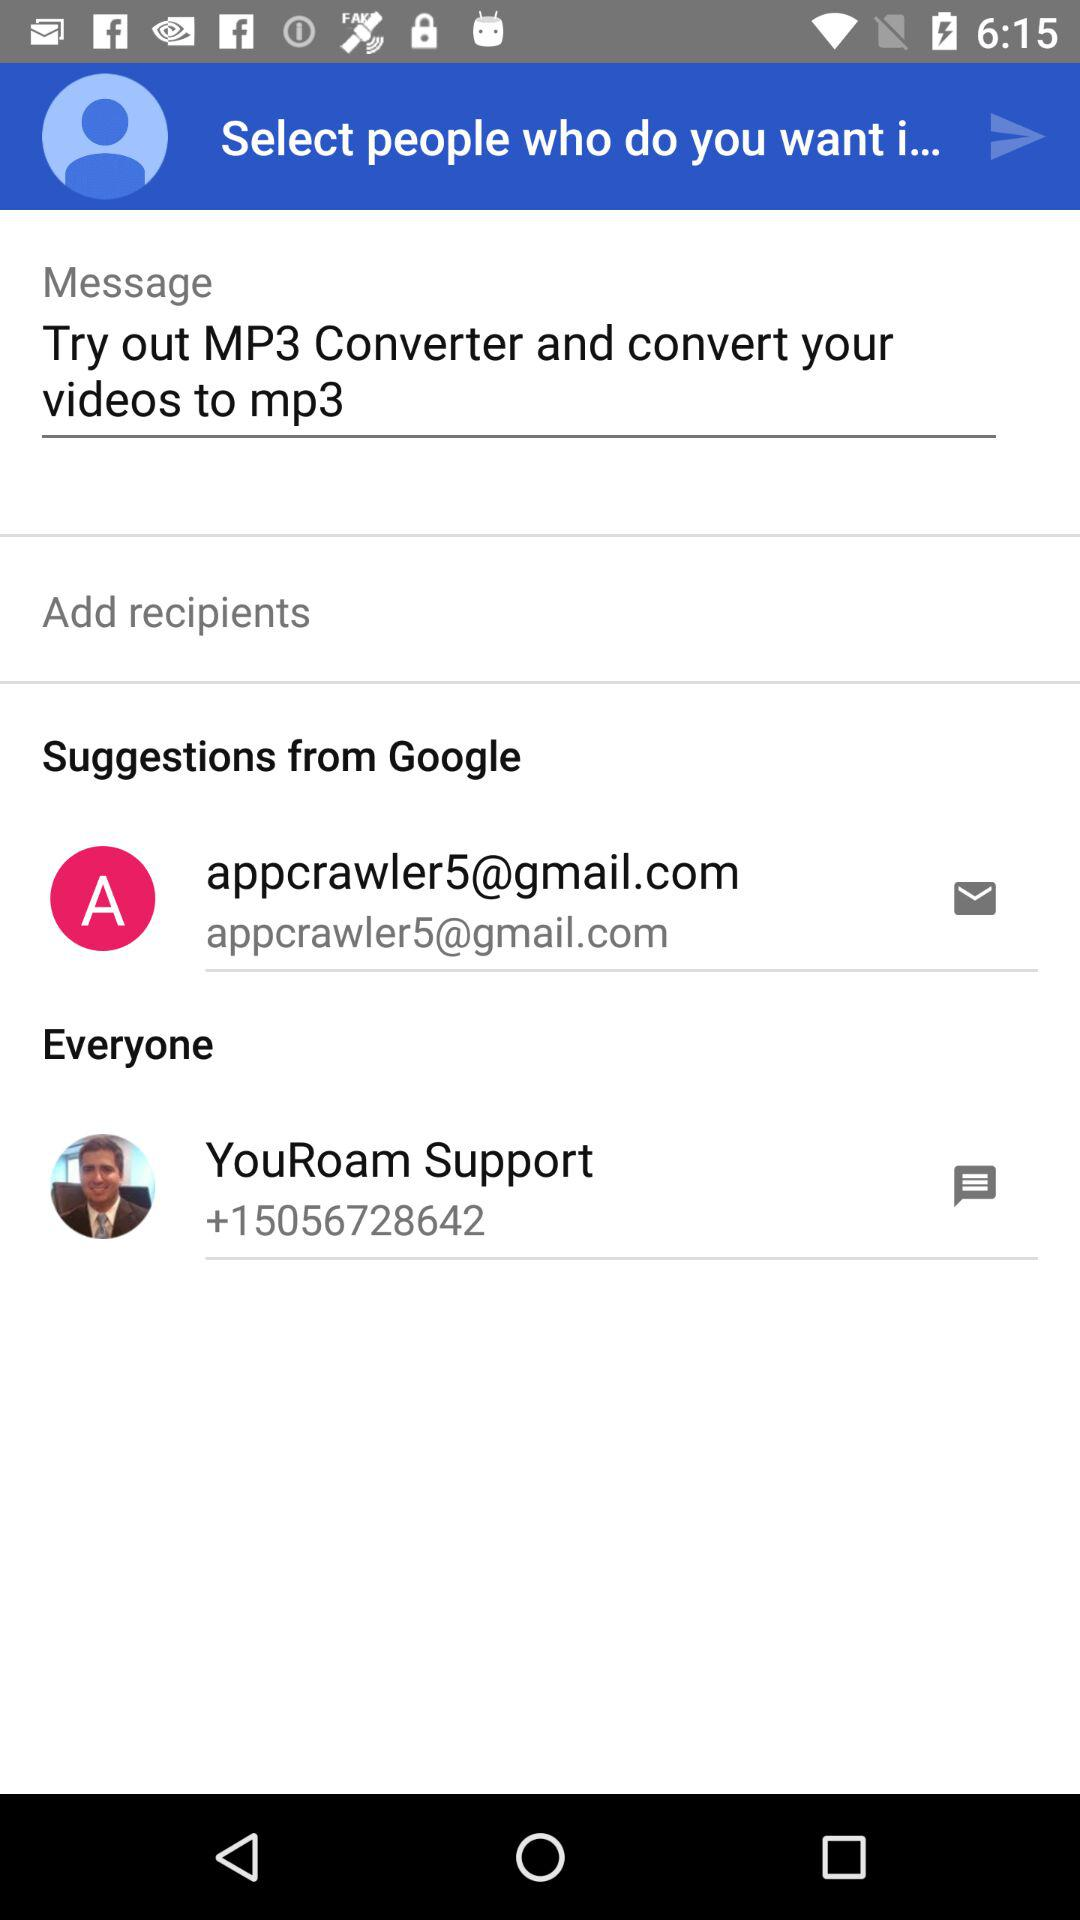What is the email address? The email address is appcrawler5@gmail.com. 